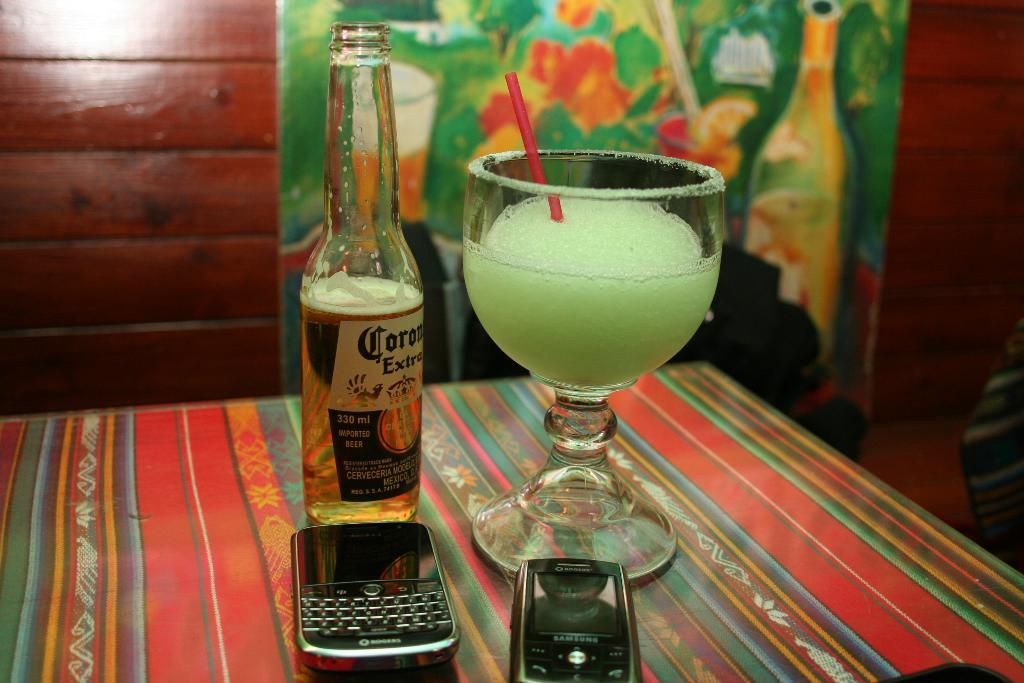<image>
Relay a brief, clear account of the picture shown. A beer that says Corona Extra is next to two cell phones and a margarita on a table. 